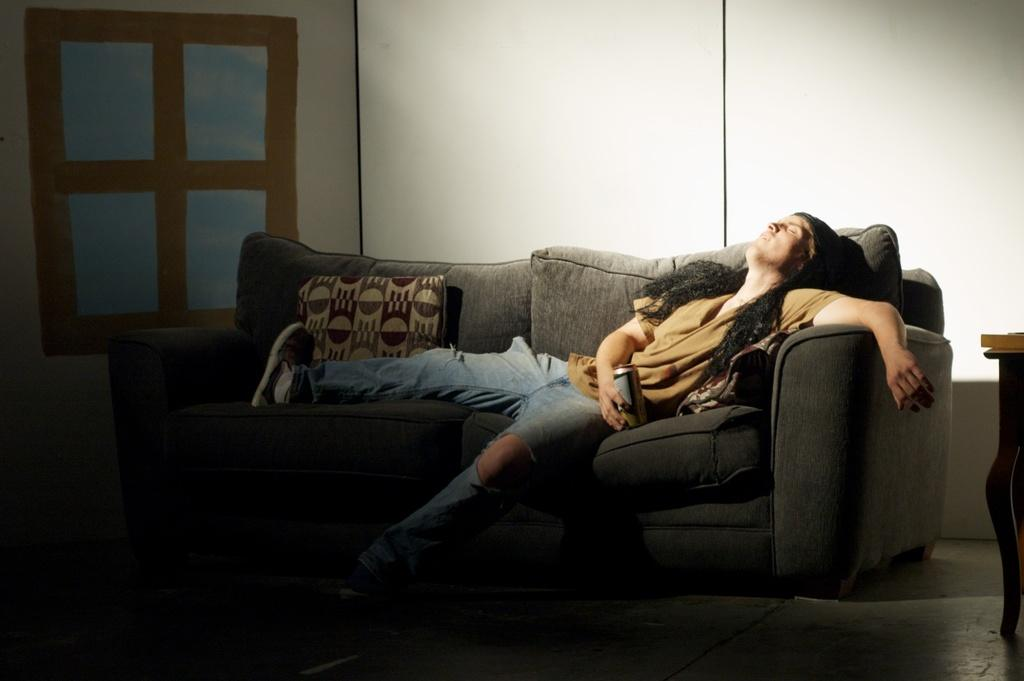Who is present in the image? There is a man in the image. What is the man doing in the image? The man is lying on a sofa. What is on the sofa with the man? There is a pillow on the sofa. What can be seen behind the sofa in the image? The background of the sofa is a white wall. What type of kite is the man flying in the image? There is no kite present in the image; the man is lying on a sofa. What unit of measurement is used to determine the size of the waves in the image? There are no waves present in the image, so no unit of measurement is applicable. 